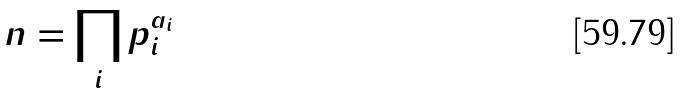Convert formula to latex. <formula><loc_0><loc_0><loc_500><loc_500>n = \prod _ { i } p _ { i } ^ { a _ { i } }</formula> 